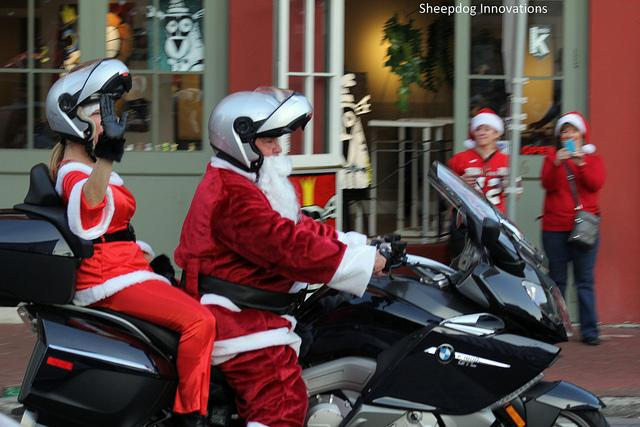Who is riding on the motorcycle? santa 